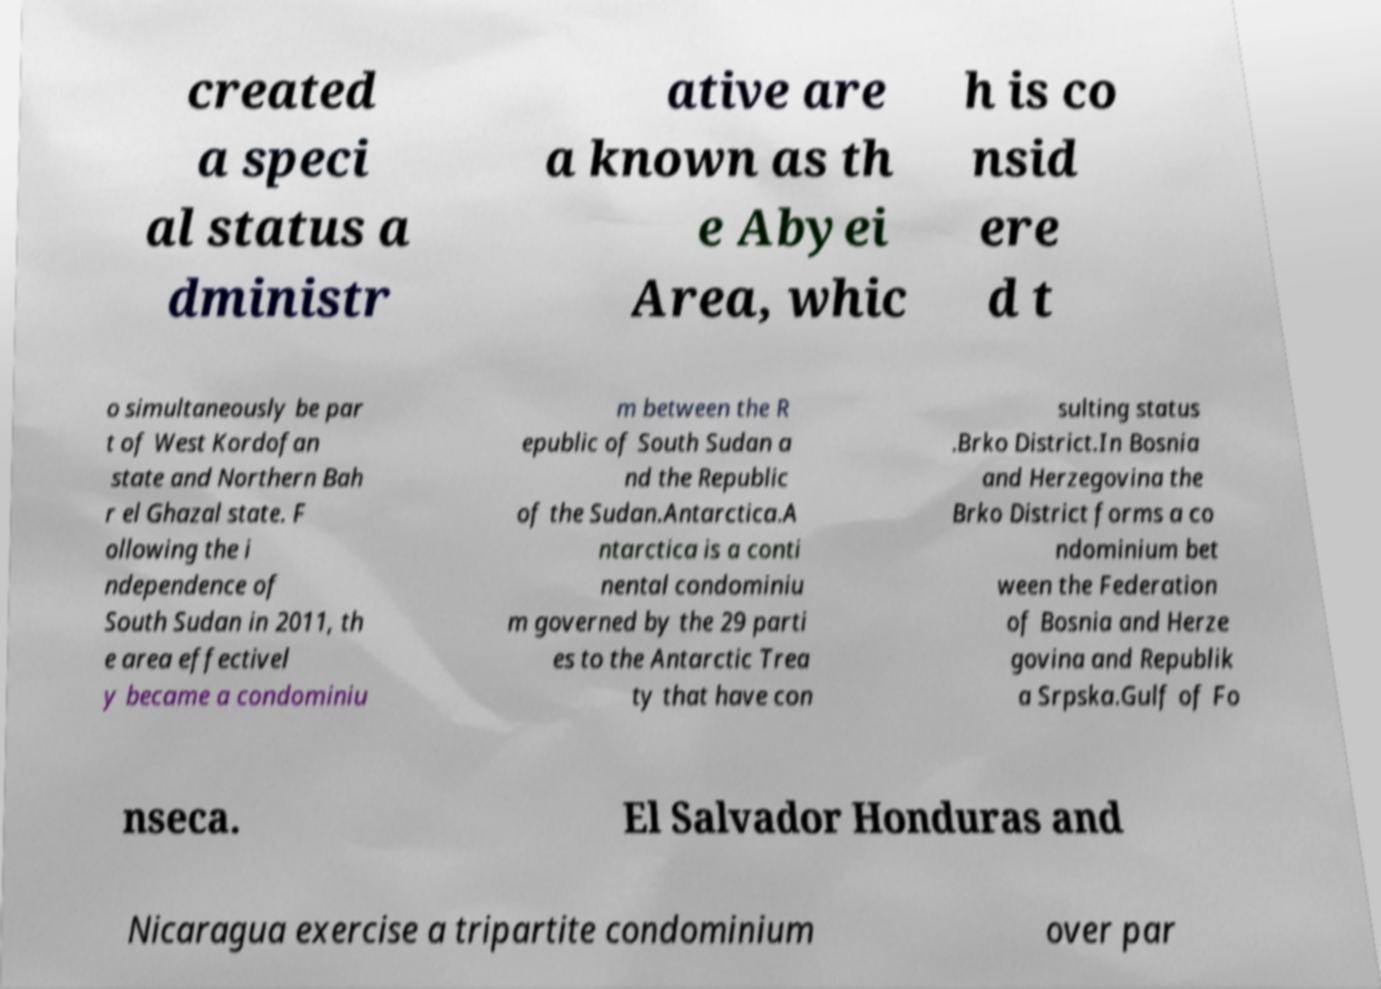Could you extract and type out the text from this image? created a speci al status a dministr ative are a known as th e Abyei Area, whic h is co nsid ere d t o simultaneously be par t of West Kordofan state and Northern Bah r el Ghazal state. F ollowing the i ndependence of South Sudan in 2011, th e area effectivel y became a condominiu m between the R epublic of South Sudan a nd the Republic of the Sudan.Antarctica.A ntarctica is a conti nental condominiu m governed by the 29 parti es to the Antarctic Trea ty that have con sulting status .Brko District.In Bosnia and Herzegovina the Brko District forms a co ndominium bet ween the Federation of Bosnia and Herze govina and Republik a Srpska.Gulf of Fo nseca. El Salvador Honduras and Nicaragua exercise a tripartite condominium over par 